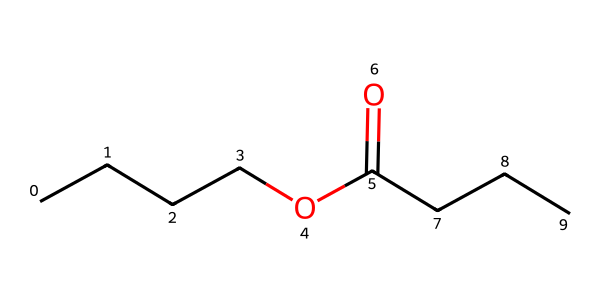What is the name of this chemical? This chemical structure corresponds to butyl butyrate, which is an ester formed from butanol and butyric acid. The presence of both an alkyl group (butyl) and a carboxylate group confirms it is an ester.
Answer: butyl butyrate How many carbon atoms are in butyl butyrate? By analyzing the SMILES representation, the part before the 'O' indicates a butyl group (4 carbon atoms), and the part after the 'O' shows another 3 carbon atoms from the butyric acid. Therefore, the total is 4 + 3 = 7.
Answer: seven What functional group defines this chemical as an ester? The presence of the carbonyl group (C=O) adjacent to an alkoxy group (–O–alkyl) in the structure identifies it as an ester. This structural arrangement is characteristic of all esters.
Answer: carbonyl What type of bond connects the carbonyl carbon to the oxygen atom? The bond between the carbonyl carbon and the oxygen atom is a single bond, specifically a sigma bond, as indicated by the representation of the ester functional group in the SMILES.
Answer: single bond Which part of the molecule contributes to its fruity scent? The butyl group is responsible for the fruity aroma, as it is a result of the specific arrangement of carbon and hydrogen atoms which are typical in aroma compounds. The overall structure is common in fruity scents.
Answer: butyl group What number of hydrogen atoms are present in butyl butyrate? To find the number of hydrogen atoms, we can count from the structural arrangement. The butyl group contributes 9 hydrogen atoms and the butyric acid provides 6 but considering connectivity and valency, the total is confirmed to be 14.
Answer: fourteen 